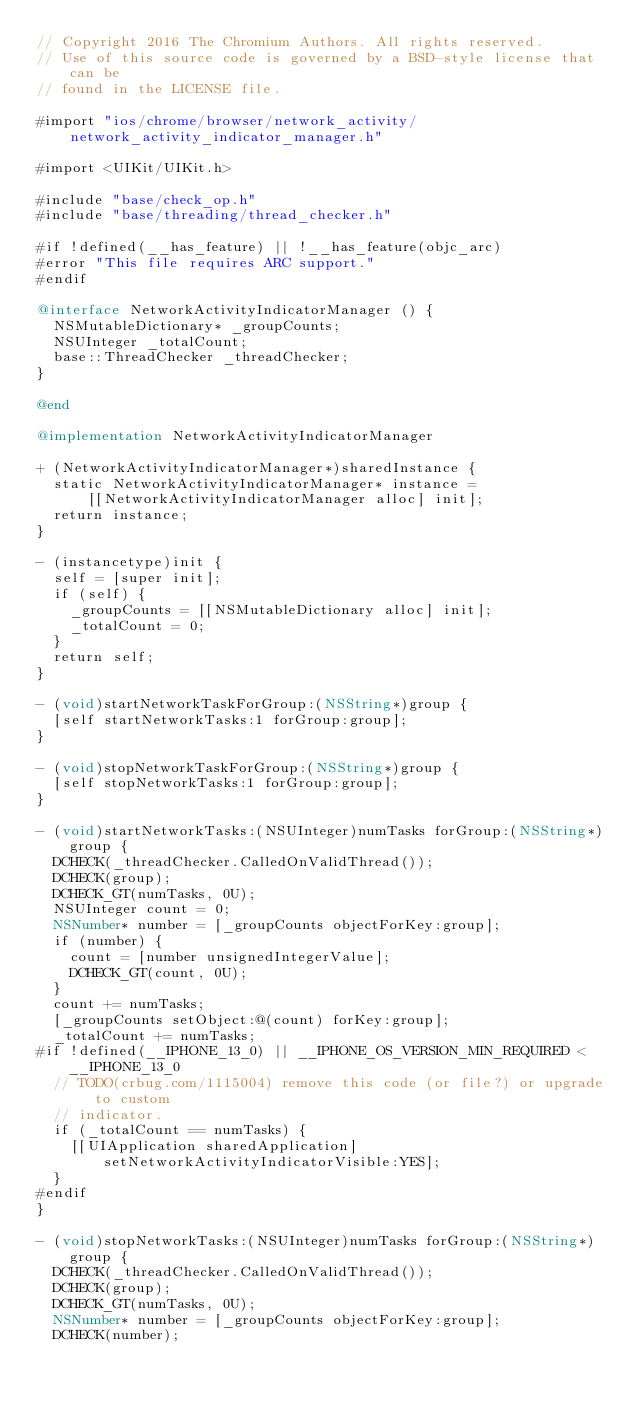<code> <loc_0><loc_0><loc_500><loc_500><_ObjectiveC_>// Copyright 2016 The Chromium Authors. All rights reserved.
// Use of this source code is governed by a BSD-style license that can be
// found in the LICENSE file.

#import "ios/chrome/browser/network_activity/network_activity_indicator_manager.h"

#import <UIKit/UIKit.h>

#include "base/check_op.h"
#include "base/threading/thread_checker.h"

#if !defined(__has_feature) || !__has_feature(objc_arc)
#error "This file requires ARC support."
#endif

@interface NetworkActivityIndicatorManager () {
  NSMutableDictionary* _groupCounts;
  NSUInteger _totalCount;
  base::ThreadChecker _threadChecker;
}

@end

@implementation NetworkActivityIndicatorManager

+ (NetworkActivityIndicatorManager*)sharedInstance {
  static NetworkActivityIndicatorManager* instance =
      [[NetworkActivityIndicatorManager alloc] init];
  return instance;
}

- (instancetype)init {
  self = [super init];
  if (self) {
    _groupCounts = [[NSMutableDictionary alloc] init];
    _totalCount = 0;
  }
  return self;
}

- (void)startNetworkTaskForGroup:(NSString*)group {
  [self startNetworkTasks:1 forGroup:group];
}

- (void)stopNetworkTaskForGroup:(NSString*)group {
  [self stopNetworkTasks:1 forGroup:group];
}

- (void)startNetworkTasks:(NSUInteger)numTasks forGroup:(NSString*)group {
  DCHECK(_threadChecker.CalledOnValidThread());
  DCHECK(group);
  DCHECK_GT(numTasks, 0U);
  NSUInteger count = 0;
  NSNumber* number = [_groupCounts objectForKey:group];
  if (number) {
    count = [number unsignedIntegerValue];
    DCHECK_GT(count, 0U);
  }
  count += numTasks;
  [_groupCounts setObject:@(count) forKey:group];
  _totalCount += numTasks;
#if !defined(__IPHONE_13_0) || __IPHONE_OS_VERSION_MIN_REQUIRED < __IPHONE_13_0
  // TODO(crbug.com/1115004) remove this code (or file?) or upgrade to custom
  // indicator.
  if (_totalCount == numTasks) {
    [[UIApplication sharedApplication] setNetworkActivityIndicatorVisible:YES];
  }
#endif
}

- (void)stopNetworkTasks:(NSUInteger)numTasks forGroup:(NSString*)group {
  DCHECK(_threadChecker.CalledOnValidThread());
  DCHECK(group);
  DCHECK_GT(numTasks, 0U);
  NSNumber* number = [_groupCounts objectForKey:group];
  DCHECK(number);</code> 